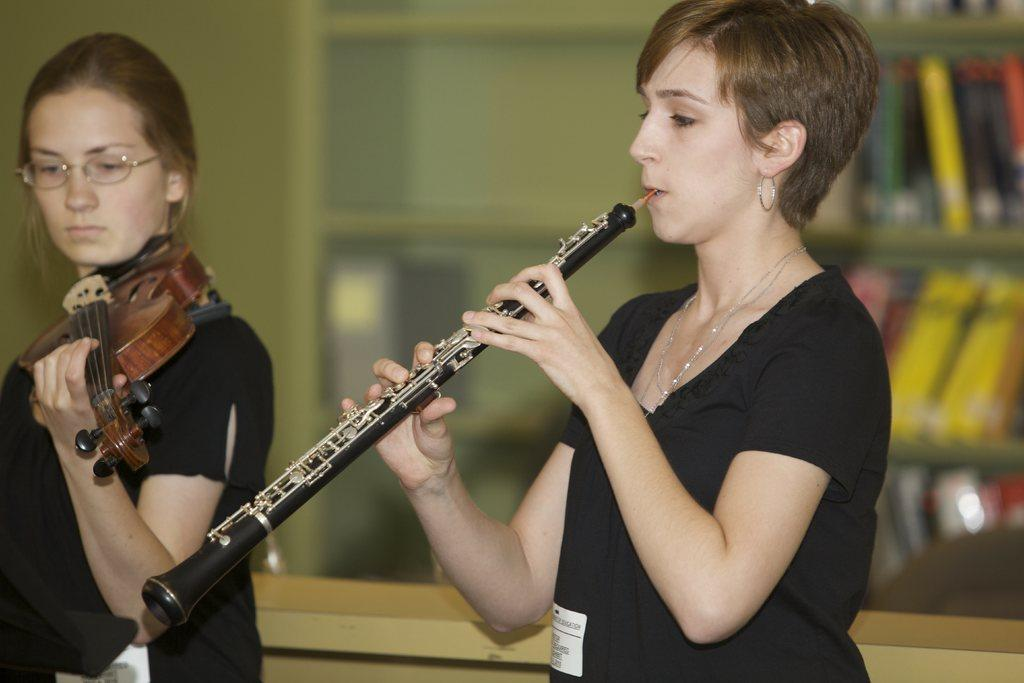What is happening in the image? There is a spectacle in the image, featuring two women holding musical instruments (clarinet and violin). What can be seen in the background of the image? There are books in racks and a wall visible in the background of the image. How is the image quality? The image is blurry. What degree of cleanliness is being maintained by the sponge in the image? There is no sponge present in the image. 